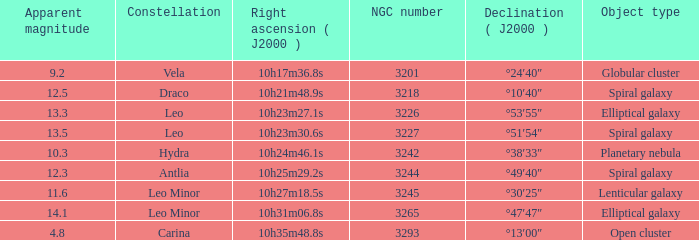What is the sum of NGC numbers for Constellation vela? 3201.0. 